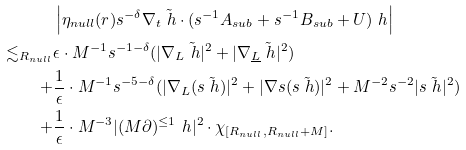Convert formula to latex. <formula><loc_0><loc_0><loc_500><loc_500>& \left | \eta _ { n u l l } ( r ) s ^ { - \delta } \nabla _ { t } \tilde { \ h } \cdot ( s ^ { - 1 } A _ { s u b } + s ^ { - 1 } B _ { s u b } + U ) \ h \right | \\ \lesssim _ { R _ { n u l l } } & \epsilon \cdot M ^ { - 1 } s ^ { - 1 - \delta } ( | \nabla _ { L } \tilde { \ h } | ^ { 2 } + | \nabla _ { \underline { L } } \tilde { \ h } | ^ { 2 } ) \\ + & \frac { 1 } { \epsilon } \cdot M ^ { - 1 } s ^ { - 5 - \delta } ( | \nabla _ { L } ( s \tilde { \ h } ) | ^ { 2 } + | \nabla s ( s \tilde { \ h } ) | ^ { 2 } + M ^ { - 2 } s ^ { - 2 } | s \tilde { \ h } | ^ { 2 } ) \\ + & \frac { 1 } { \epsilon } \cdot M ^ { - 3 } | ( M \partial ) ^ { \leq 1 } \ h | ^ { 2 } \cdot \chi _ { [ R _ { n u l l } , R _ { n u l l } + M ] } .</formula> 